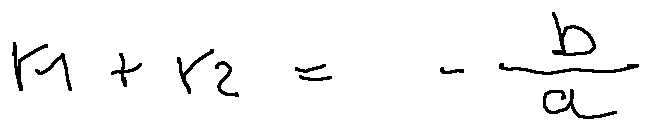<formula> <loc_0><loc_0><loc_500><loc_500>r _ { 1 } + r _ { 2 } = - \frac { b } { a }</formula> 